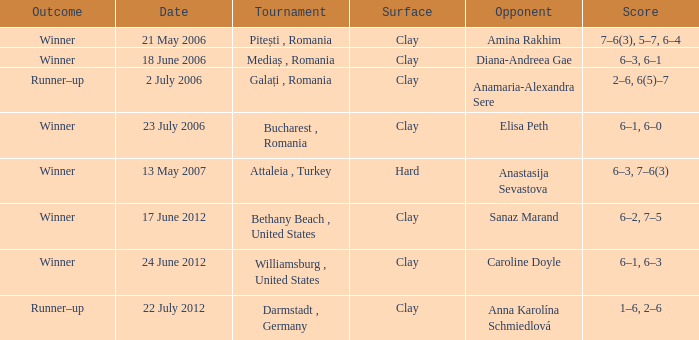What tournament was held on 21 May 2006? Pitești , Romania. 